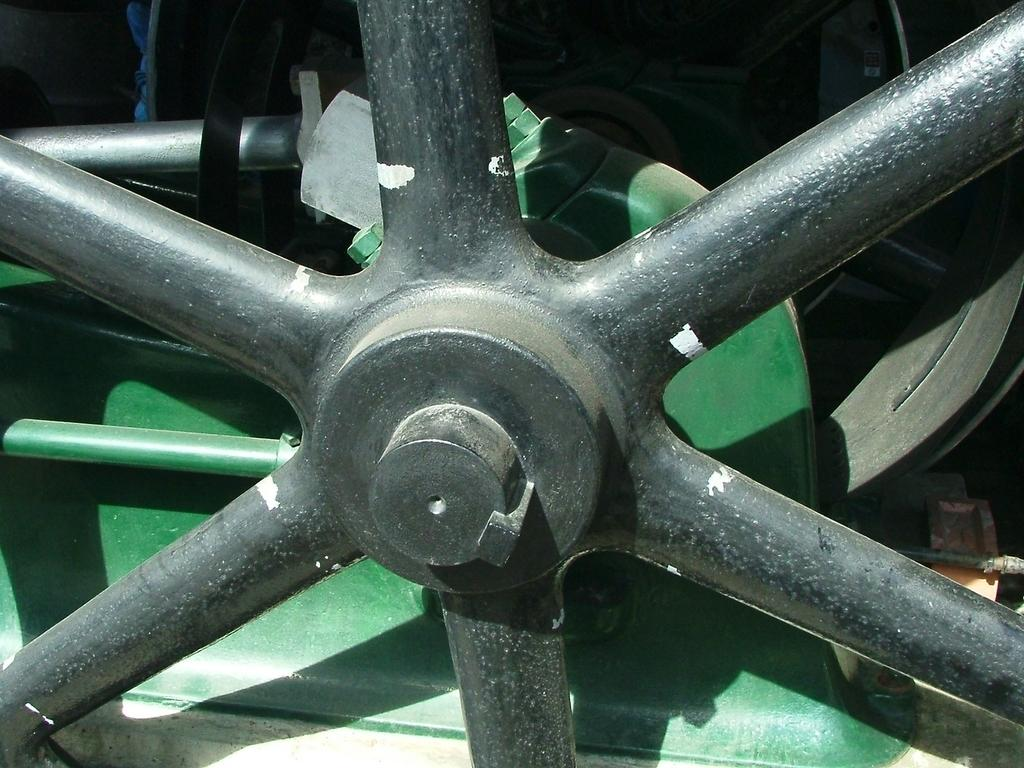What is the main subject of the image? The main subject of the image is a train's wheel. Are there any other objects in the image besides the train's wheel? Yes, there is a green color box in the image. Where is the key located in the image? There is no key present in the image. What is the mother doing in the image? There is no mother or any human figure present in the image. 